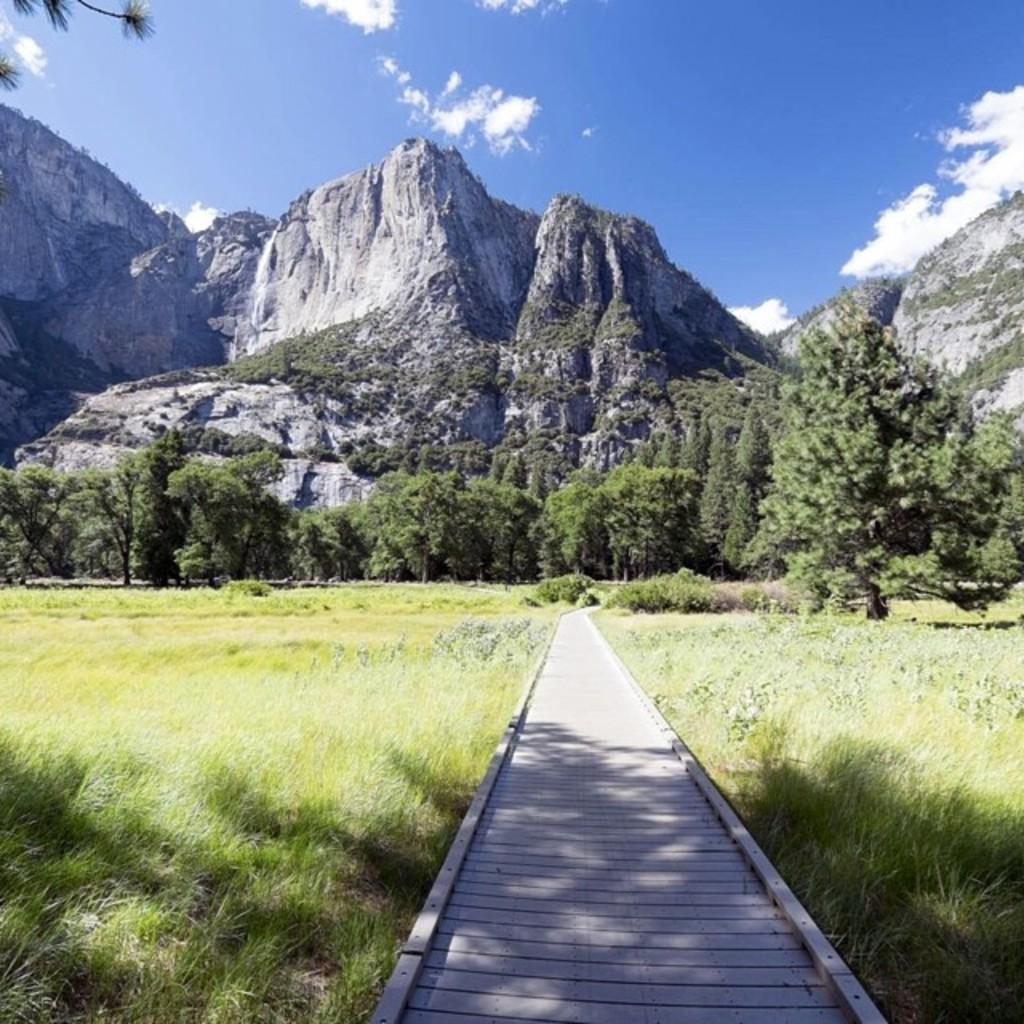Please provide a concise description of this image. There is a wooden path. On the sides there are grasses. In the background there are trees, hills and sky with clouds. 